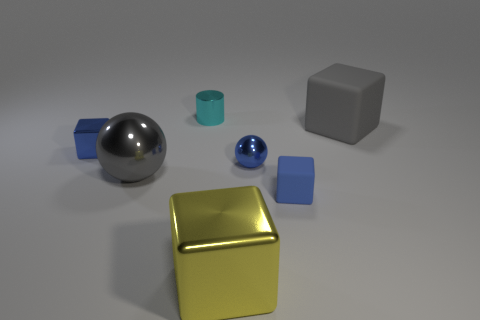Is the color of the big rubber thing the same as the big metal ball?
Your answer should be compact. Yes. What number of objects are either metallic cubes that are left of the yellow cube or tiny red matte blocks?
Offer a very short reply. 1. There is a metal cube to the right of the blue cube that is on the left side of the big yellow metallic cube; how many tiny cyan metal things are behind it?
Provide a short and direct response. 1. There is a small shiny thing that is behind the tiny cube behind the small object on the right side of the tiny ball; what is its shape?
Your answer should be very brief. Cylinder. How many other objects are there of the same color as the big rubber cube?
Keep it short and to the point. 1. What is the shape of the gray thing in front of the matte thing behind the small blue sphere?
Make the answer very short. Sphere. There is a cyan shiny cylinder; how many tiny cylinders are behind it?
Offer a very short reply. 0. Are there any tiny gray blocks made of the same material as the yellow thing?
Offer a terse response. No. What material is the ball that is the same size as the yellow metallic thing?
Provide a succinct answer. Metal. There is a block that is on the left side of the tiny blue matte cube and in front of the big gray sphere; what size is it?
Your response must be concise. Large. 